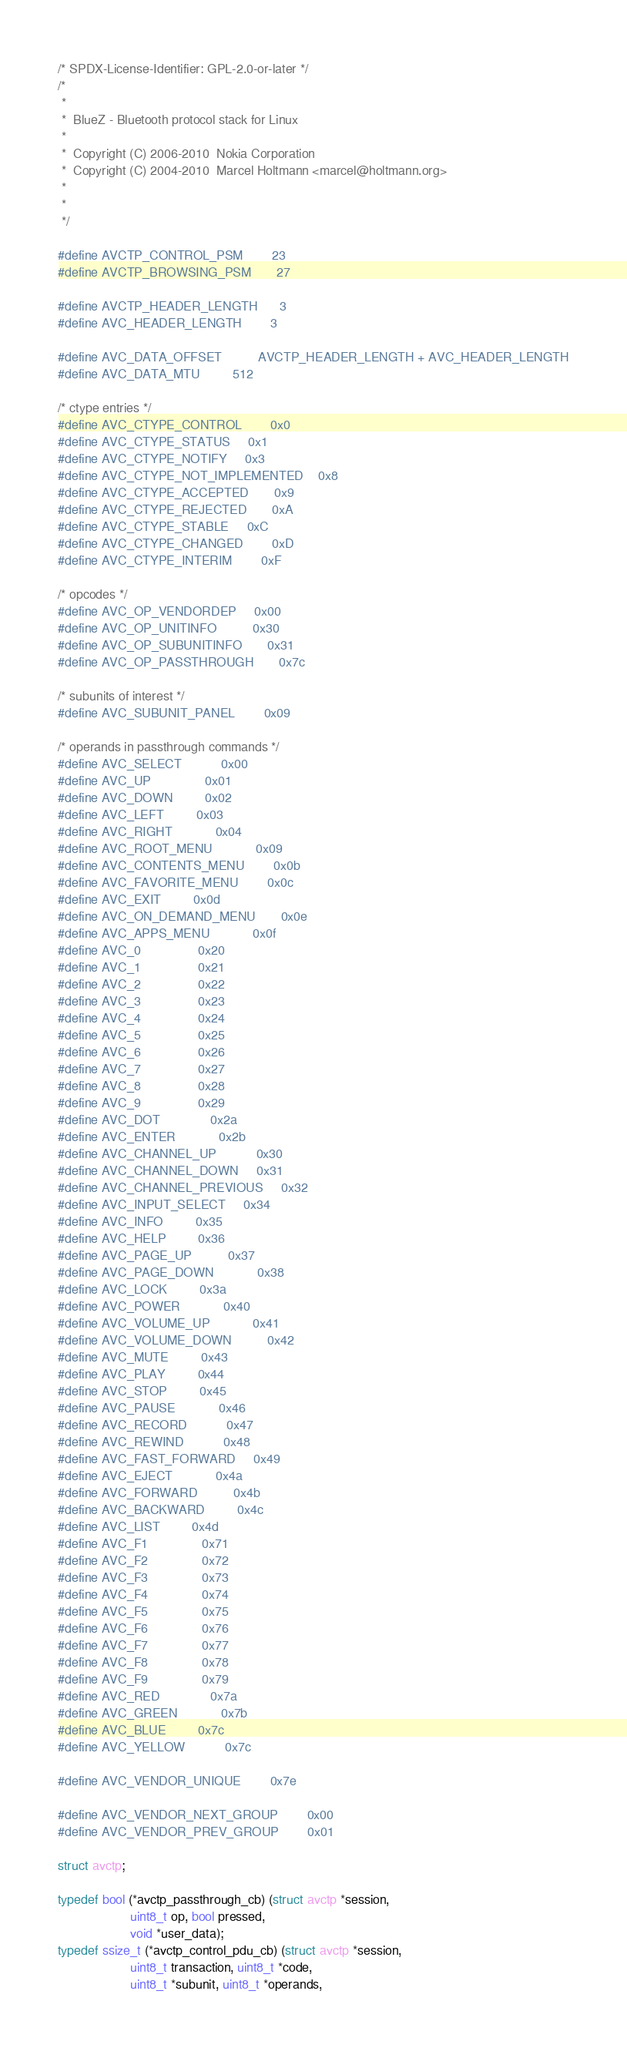<code> <loc_0><loc_0><loc_500><loc_500><_C_>/* SPDX-License-Identifier: GPL-2.0-or-later */
/*
 *
 *  BlueZ - Bluetooth protocol stack for Linux
 *
 *  Copyright (C) 2006-2010  Nokia Corporation
 *  Copyright (C) 2004-2010  Marcel Holtmann <marcel@holtmann.org>
 *
 *
 */

#define AVCTP_CONTROL_PSM		23
#define AVCTP_BROWSING_PSM		27

#define AVCTP_HEADER_LENGTH		3
#define AVC_HEADER_LENGTH		3

#define AVC_DATA_OFFSET			AVCTP_HEADER_LENGTH + AVC_HEADER_LENGTH
#define AVC_DATA_MTU			512

/* ctype entries */
#define AVC_CTYPE_CONTROL		0x0
#define AVC_CTYPE_STATUS		0x1
#define AVC_CTYPE_NOTIFY		0x3
#define AVC_CTYPE_NOT_IMPLEMENTED	0x8
#define AVC_CTYPE_ACCEPTED		0x9
#define AVC_CTYPE_REJECTED		0xA
#define AVC_CTYPE_STABLE		0xC
#define AVC_CTYPE_CHANGED		0xD
#define AVC_CTYPE_INTERIM		0xF

/* opcodes */
#define AVC_OP_VENDORDEP		0x00
#define AVC_OP_UNITINFO			0x30
#define AVC_OP_SUBUNITINFO		0x31
#define AVC_OP_PASSTHROUGH		0x7c

/* subunits of interest */
#define AVC_SUBUNIT_PANEL		0x09

/* operands in passthrough commands */
#define AVC_SELECT			0x00
#define AVC_UP				0x01
#define AVC_DOWN			0x02
#define AVC_LEFT			0x03
#define AVC_RIGHT			0x04
#define AVC_ROOT_MENU			0x09
#define AVC_CONTENTS_MENU		0x0b
#define AVC_FAVORITE_MENU		0x0c
#define AVC_EXIT			0x0d
#define AVC_ON_DEMAND_MENU		0x0e
#define AVC_APPS_MENU			0x0f
#define AVC_0				0x20
#define AVC_1				0x21
#define AVC_2				0x22
#define AVC_3				0x23
#define AVC_4				0x24
#define AVC_5				0x25
#define AVC_6				0x26
#define AVC_7				0x27
#define AVC_8				0x28
#define AVC_9				0x29
#define AVC_DOT				0x2a
#define AVC_ENTER			0x2b
#define AVC_CHANNEL_UP			0x30
#define AVC_CHANNEL_DOWN		0x31
#define AVC_CHANNEL_PREVIOUS		0x32
#define AVC_INPUT_SELECT		0x34
#define AVC_INFO			0x35
#define AVC_HELP			0x36
#define AVC_PAGE_UP			0x37
#define AVC_PAGE_DOWN			0x38
#define AVC_LOCK			0x3a
#define AVC_POWER			0x40
#define AVC_VOLUME_UP			0x41
#define AVC_VOLUME_DOWN			0x42
#define AVC_MUTE			0x43
#define AVC_PLAY			0x44
#define AVC_STOP			0x45
#define AVC_PAUSE			0x46
#define AVC_RECORD			0x47
#define AVC_REWIND			0x48
#define AVC_FAST_FORWARD		0x49
#define AVC_EJECT			0x4a
#define AVC_FORWARD			0x4b
#define AVC_BACKWARD			0x4c
#define AVC_LIST			0x4d
#define AVC_F1				0x71
#define AVC_F2				0x72
#define AVC_F3				0x73
#define AVC_F4				0x74
#define AVC_F5				0x75
#define AVC_F6				0x76
#define AVC_F7				0x77
#define AVC_F8				0x78
#define AVC_F9				0x79
#define AVC_RED				0x7a
#define AVC_GREEN			0x7b
#define AVC_BLUE			0x7c
#define AVC_YELLOW			0x7c

#define AVC_VENDOR_UNIQUE		0x7e

#define AVC_VENDOR_NEXT_GROUP		0x00
#define AVC_VENDOR_PREV_GROUP		0x01

struct avctp;

typedef bool (*avctp_passthrough_cb) (struct avctp *session,
					uint8_t op, bool pressed,
					void *user_data);
typedef ssize_t (*avctp_control_pdu_cb) (struct avctp *session,
					uint8_t transaction, uint8_t *code,
					uint8_t *subunit, uint8_t *operands,</code> 